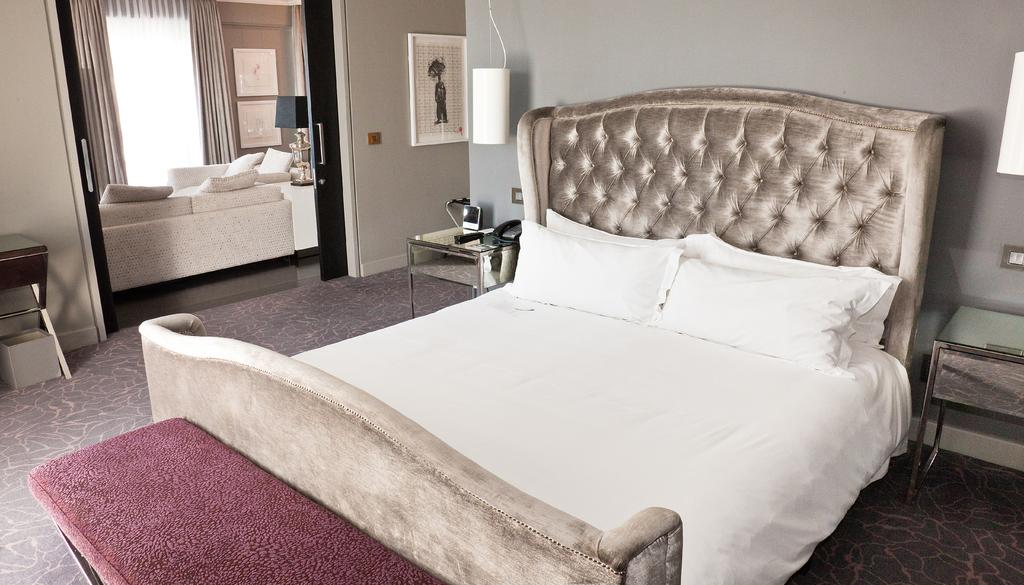What type of furniture is present in the room? There is a bed, a table, and sofas in the room. Where is the lamp located in the room? There is a lamp on the right side of the room. What can be used for holding objects in the room? There is a table in the room that can be used for holding objects. What type of decorative items are in the room? There are photo frames in the room. Are there any additional light sources in the room? Yes, there are additional lamps in the room. What type of grass can be seen growing on the scale in the room? There is no grass or scale present in the room; the image only features a bed, a table, sofas, photo frames, and lamps. 